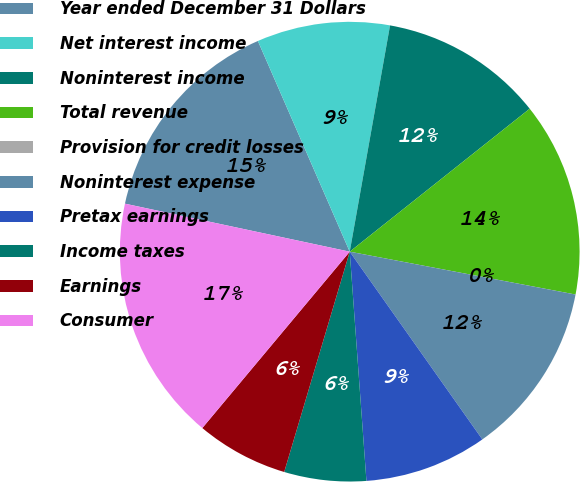Convert chart. <chart><loc_0><loc_0><loc_500><loc_500><pie_chart><fcel>Year ended December 31 Dollars<fcel>Net interest income<fcel>Noninterest income<fcel>Total revenue<fcel>Provision for credit losses<fcel>Noninterest expense<fcel>Pretax earnings<fcel>Income taxes<fcel>Earnings<fcel>Consumer<nl><fcel>15.11%<fcel>9.35%<fcel>11.51%<fcel>13.67%<fcel>0.0%<fcel>12.23%<fcel>8.63%<fcel>5.76%<fcel>6.48%<fcel>17.27%<nl></chart> 